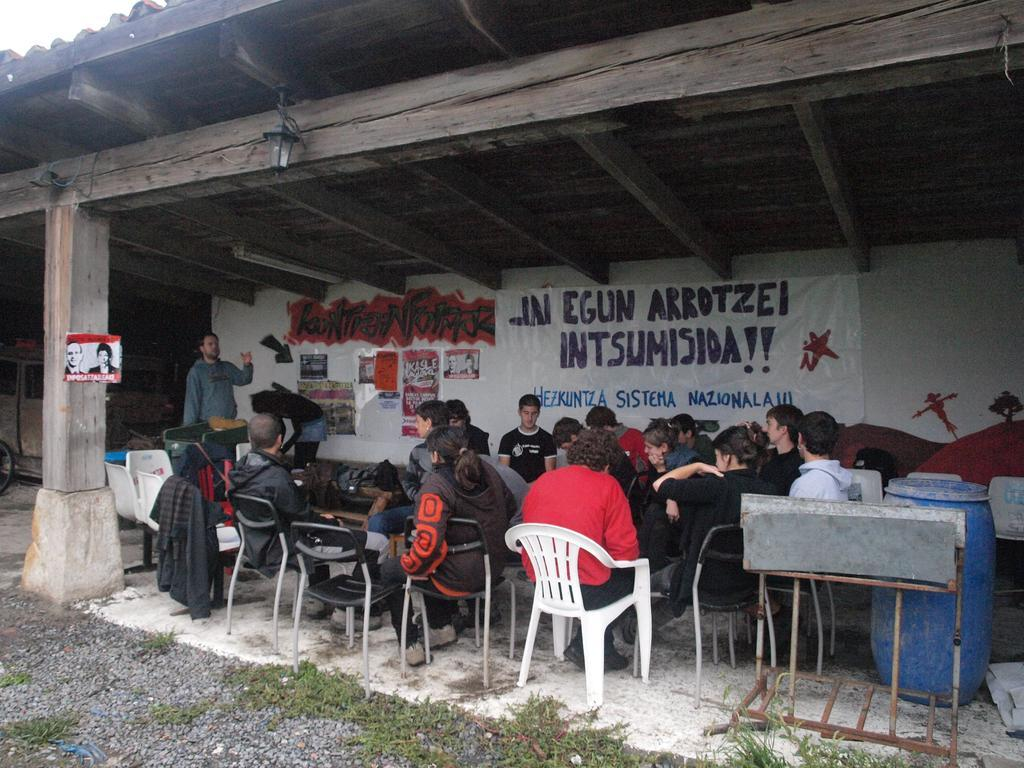What type of structure can be seen in the image? There is a wall in the image. What is hanging on the wall? There is a banner in the image. What are the people in the image doing? The people are sitting on chairs in the image. What piece of furniture is present in the image? There is a table in the image. What musical instrument can be seen on the right side of the image? There is a drum on the right side of the image. Can you tell me how many spoons are being used to copy the banner in the image? There are no spoons or copying activities present in the image. What type of bat is flying near the drum in the image? There are no bats present in the image; it only features a drum on the right side. 